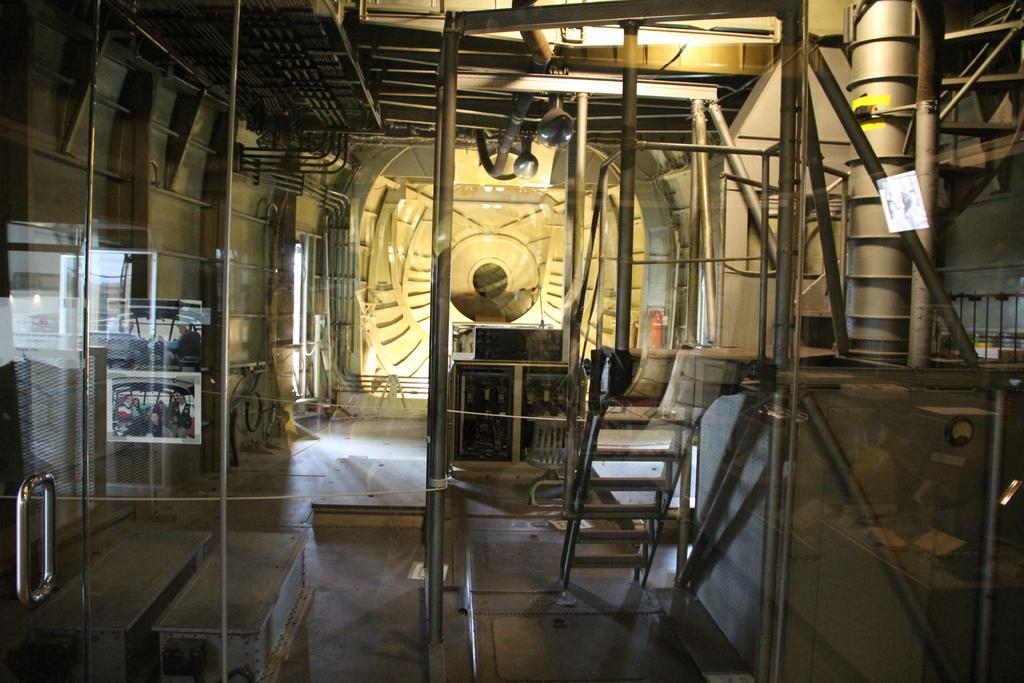What type of space is depicted in the image? The image is an interior of a room. What architectural feature can be seen in the room? There is a glass door in the room. What is another feature of the room? There is a staircase in the room. What type of decorations are present in the room? Photos are present in the room. What other structural elements can be seen in the room? Poles and rods are visible in the room. Can you describe any other objects in the room? There are other objects in the room, but their specific details are not mentioned in the provided facts. Where is the map located in the room? There is no map present in the image. Is there a beggar visible in the room? There is no beggar present in the image. 